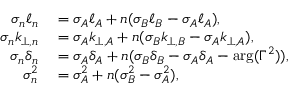<formula> <loc_0><loc_0><loc_500><loc_500>\begin{array} { r l } { \sigma _ { n } \ell _ { n } } & = \sigma _ { A } \ell _ { A } + n ( \sigma _ { B } \ell _ { B } - \sigma _ { A } \ell _ { A } ) , } \\ { \sigma _ { n } k _ { \perp , n } } & = \sigma _ { A } k _ { \perp , A } + n ( \sigma _ { B } k _ { \perp , B } - \sigma _ { A } k _ { \perp , A } ) , } \\ { \sigma _ { n } \delta _ { n } } & = \sigma _ { A } \delta _ { A } + n ( \sigma _ { B } \delta _ { B } - \sigma _ { A } \delta _ { A } - \arg ( \Gamma ^ { 2 } ) ) , } \\ { \sigma _ { n } ^ { 2 } } & = \sigma _ { A } ^ { 2 } + n ( \sigma _ { B } ^ { 2 } - \sigma _ { A } ^ { 2 } ) , } \end{array}</formula> 